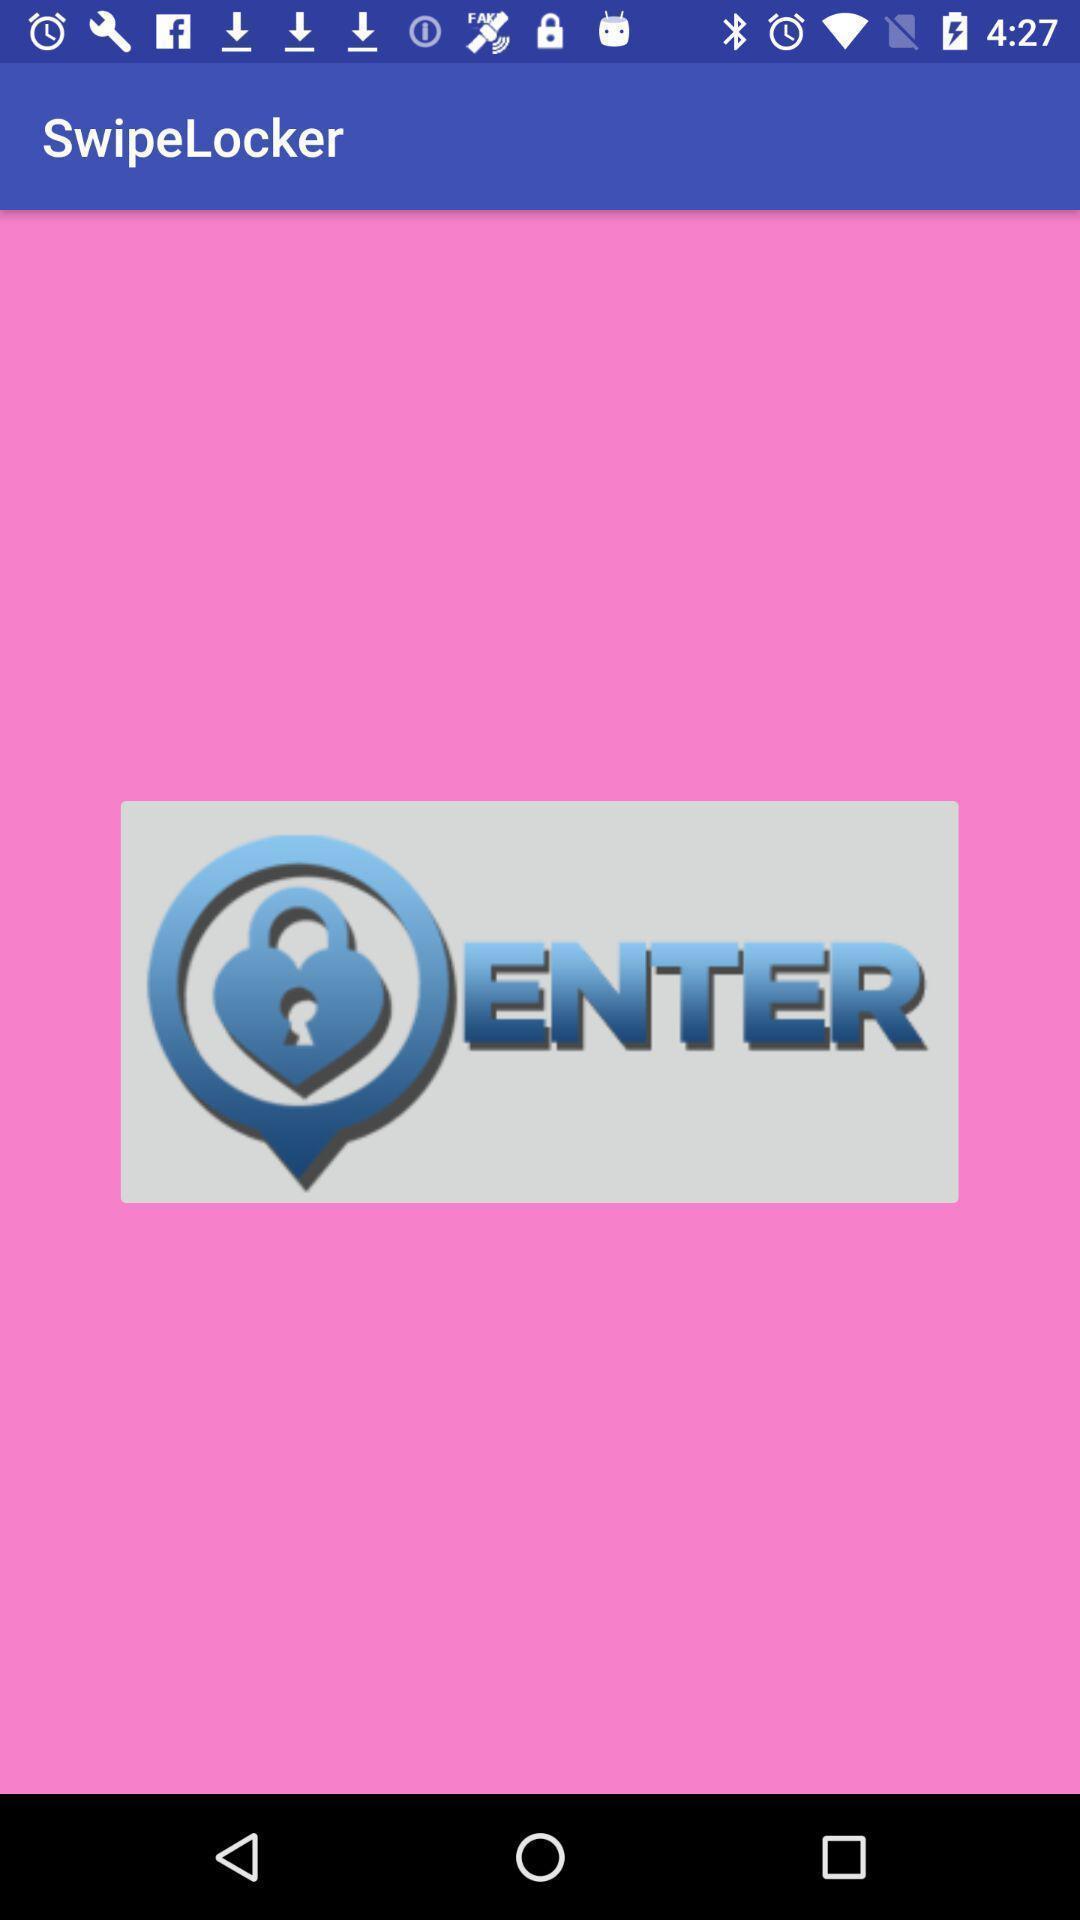Provide a detailed account of this screenshot. Welcome page for dating app. 